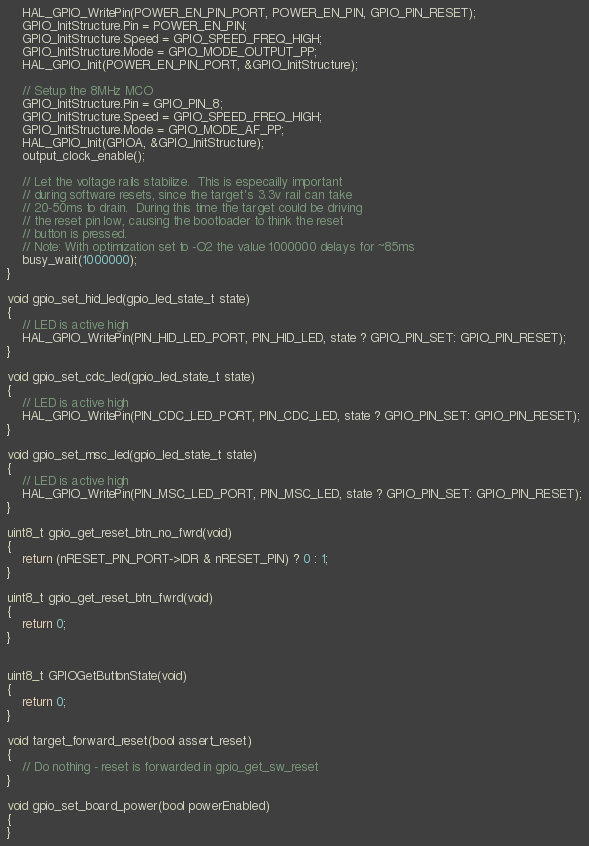<code> <loc_0><loc_0><loc_500><loc_500><_C_>    HAL_GPIO_WritePin(POWER_EN_PIN_PORT, POWER_EN_PIN, GPIO_PIN_RESET);
    GPIO_InitStructure.Pin = POWER_EN_PIN;
    GPIO_InitStructure.Speed = GPIO_SPEED_FREQ_HIGH;
    GPIO_InitStructure.Mode = GPIO_MODE_OUTPUT_PP;
    HAL_GPIO_Init(POWER_EN_PIN_PORT, &GPIO_InitStructure);

    // Setup the 8MHz MCO
    GPIO_InitStructure.Pin = GPIO_PIN_8;
    GPIO_InitStructure.Speed = GPIO_SPEED_FREQ_HIGH;
    GPIO_InitStructure.Mode = GPIO_MODE_AF_PP;
    HAL_GPIO_Init(GPIOA, &GPIO_InitStructure);
    output_clock_enable();

    // Let the voltage rails stabilize.  This is especailly important
    // during software resets, since the target's 3.3v rail can take
    // 20-50ms to drain.  During this time the target could be driving
    // the reset pin low, causing the bootloader to think the reset
    // button is pressed.
    // Note: With optimization set to -O2 the value 1000000 delays for ~85ms
    busy_wait(1000000);
}

void gpio_set_hid_led(gpio_led_state_t state)
{
    // LED is active high
	HAL_GPIO_WritePin(PIN_HID_LED_PORT, PIN_HID_LED, state ? GPIO_PIN_SET: GPIO_PIN_RESET);
}

void gpio_set_cdc_led(gpio_led_state_t state)
{
    // LED is active high
    HAL_GPIO_WritePin(PIN_CDC_LED_PORT, PIN_CDC_LED, state ? GPIO_PIN_SET: GPIO_PIN_RESET);
}

void gpio_set_msc_led(gpio_led_state_t state)
{
    // LED is active high
    HAL_GPIO_WritePin(PIN_MSC_LED_PORT, PIN_MSC_LED, state ? GPIO_PIN_SET: GPIO_PIN_RESET);
}

uint8_t gpio_get_reset_btn_no_fwrd(void)
{
    return (nRESET_PIN_PORT->IDR & nRESET_PIN) ? 0 : 1;
}

uint8_t gpio_get_reset_btn_fwrd(void)
{
    return 0;
}


uint8_t GPIOGetButtonState(void)
{
    return 0;
}

void target_forward_reset(bool assert_reset)
{
    // Do nothing - reset is forwarded in gpio_get_sw_reset
}

void gpio_set_board_power(bool powerEnabled)
{
}
</code> 